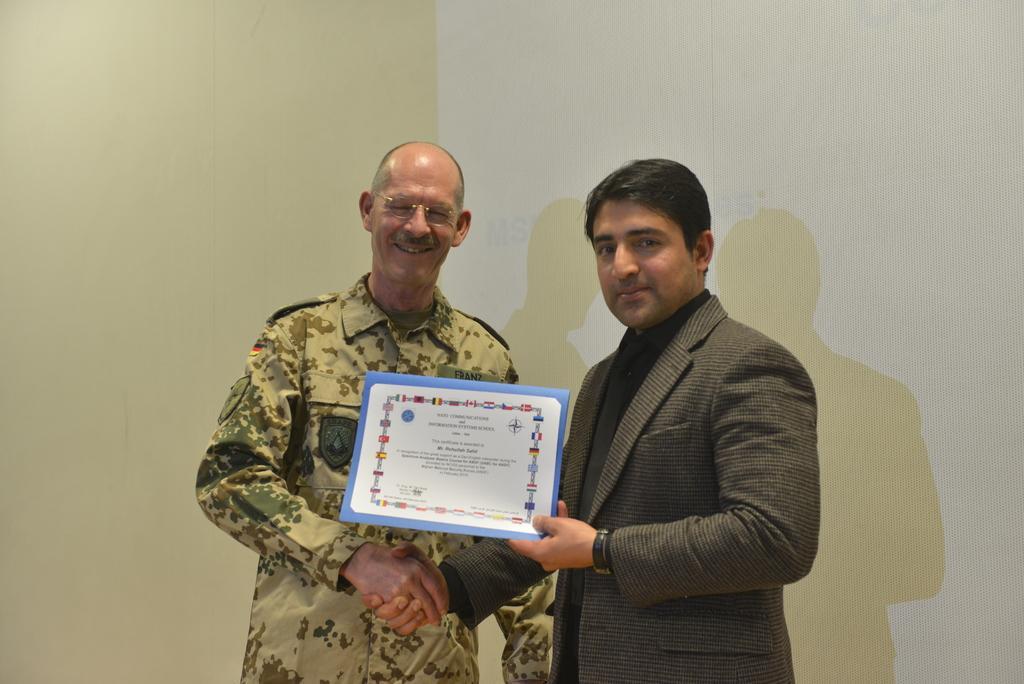Could you give a brief overview of what you see in this image? In the picture there are two men, the second person is presenting an award and giving shake hand to the first person, in the background there is a wall. 